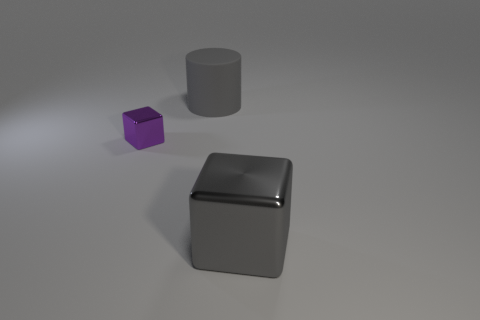Is the number of metallic things less than the number of small cyan shiny balls?
Give a very brief answer. No. There is a thing that is on the left side of the big metal object and to the right of the purple shiny cube; what material is it?
Ensure brevity in your answer.  Rubber. There is a big object that is behind the small purple shiny object; is there a small purple shiny object that is in front of it?
Provide a short and direct response. Yes. How many other objects have the same color as the big matte thing?
Make the answer very short. 1. There is a large thing that is the same color as the big shiny cube; what material is it?
Your answer should be compact. Rubber. Is the material of the purple object the same as the gray cube?
Keep it short and to the point. Yes. Are there any purple metallic cubes to the right of the big rubber cylinder?
Your response must be concise. No. There is a big block that is right of the metal block that is behind the big shiny thing; what is its material?
Make the answer very short. Metal. The other purple thing that is the same shape as the large metal thing is what size?
Your answer should be compact. Small. Does the rubber thing have the same color as the large metal block?
Provide a short and direct response. Yes. 